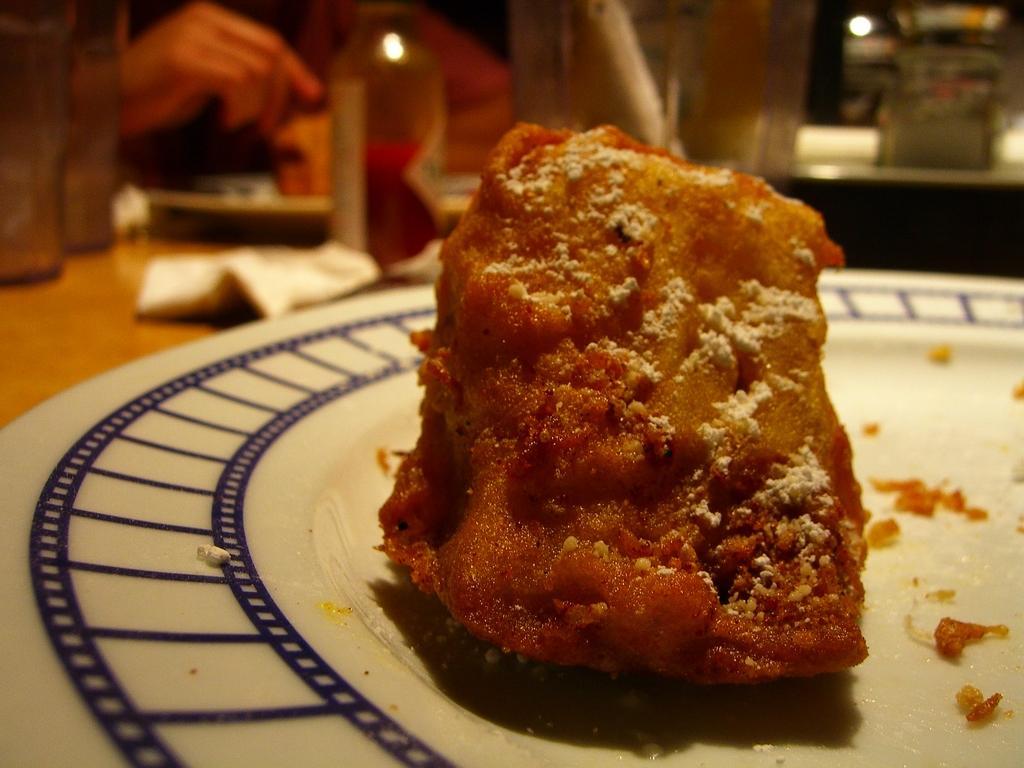Can you describe this image briefly? This is a zoomed in picture. In the foreground there is a white color palette containing some food item. In the background there is a person seems to be sitting on the chair and there is a table on the top of which a bottle, glasses and some other objects are placed. 